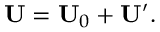Convert formula to latex. <formula><loc_0><loc_0><loc_500><loc_500>U = U _ { 0 } + U ^ { \prime } .</formula> 